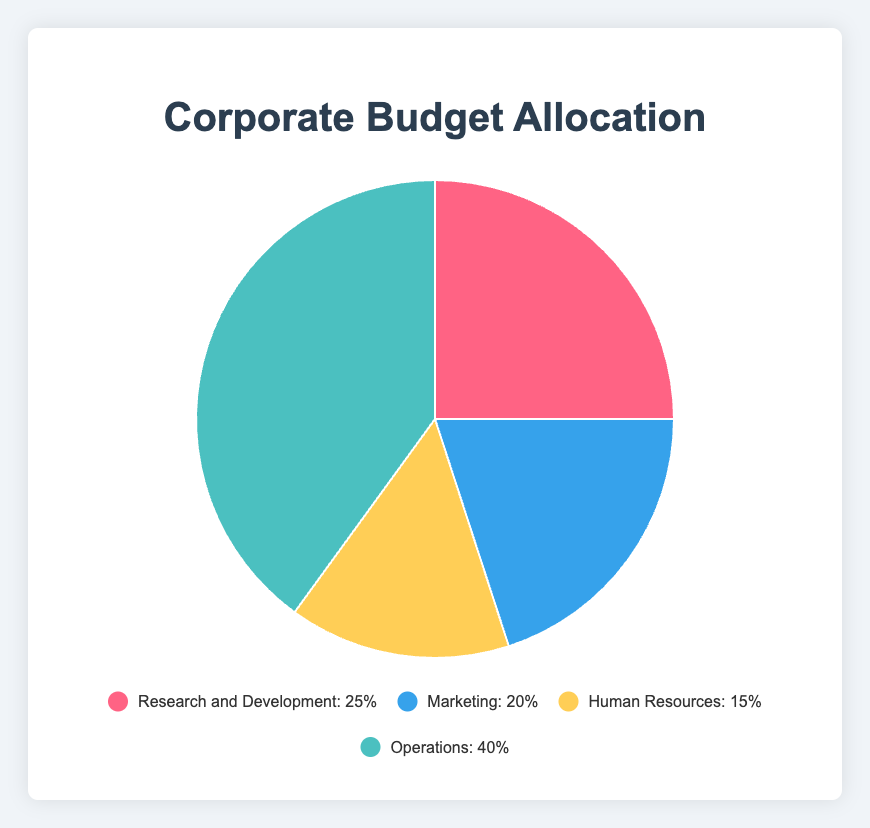Which department has the highest budget allocation? The pie chart shows four departments with their respective budget allocations. "Operations" has the largest slice.
Answer: Operations Which department has the smallest budget allocation? The pie chart shows four departments with their respective budget allocations. "Human Resources" has the smallest slice.
Answer: Human Resources What percentage of the budget is allocated to Research and Development and Marketing combined? The pie chart shows the percentages for each department. Add the budget allocations for Research and Development (25%) and Marketing (20%): 25% + 20%.
Answer: 45% How much more budget is allocated to Operations compared to Human Resources? The pie chart shows the percentages. The budget for Operations is 40% and for Human Resources is 15%. Subtract the smaller percentage from the larger one: 40% - 15%.
Answer: 25% Which department's budget allocation is 5% less than that of Research and Development? Compare the given budget allocations to find the one that is 5% less than 25% (Research and Development). Marketing has 20%, which is 25% - 5%.
Answer: Marketing What is the ratio of the budget allocation of Operations to Marketing? The pie chart shows the percentages. Divide the budget allocation of Operations (40%) by that of Marketing (20%): 40 / 20.
Answer: 2:1 How is the budget allocation for Marketing visually represented in terms of color? The pie chart indicates the color of each department's slice. Marketing is represented by a blue slice.
Answer: Blue What is the total budget allocation for all the departments displayed in the pie chart? The pie chart represents 100% of the budget. Adding all departments' percentages: 25% + 20% + 15% + 40%.
Answer: 100% Compare the combined budget allocation of Operations and Human Resources to the allocation of Research and Development. Add the percentages of Operations (40%) and Human Resources (15%) and compare to Research and Development (25%): 40% + 15% = 55%, which is greater than 25%.
Answer: 55% is greater than 25% What percentage of the budget remains if we exclude Operations? Subtract the percentage of Operations (40%) from the total budget (100%): 100% - 40%.
Answer: 60% 